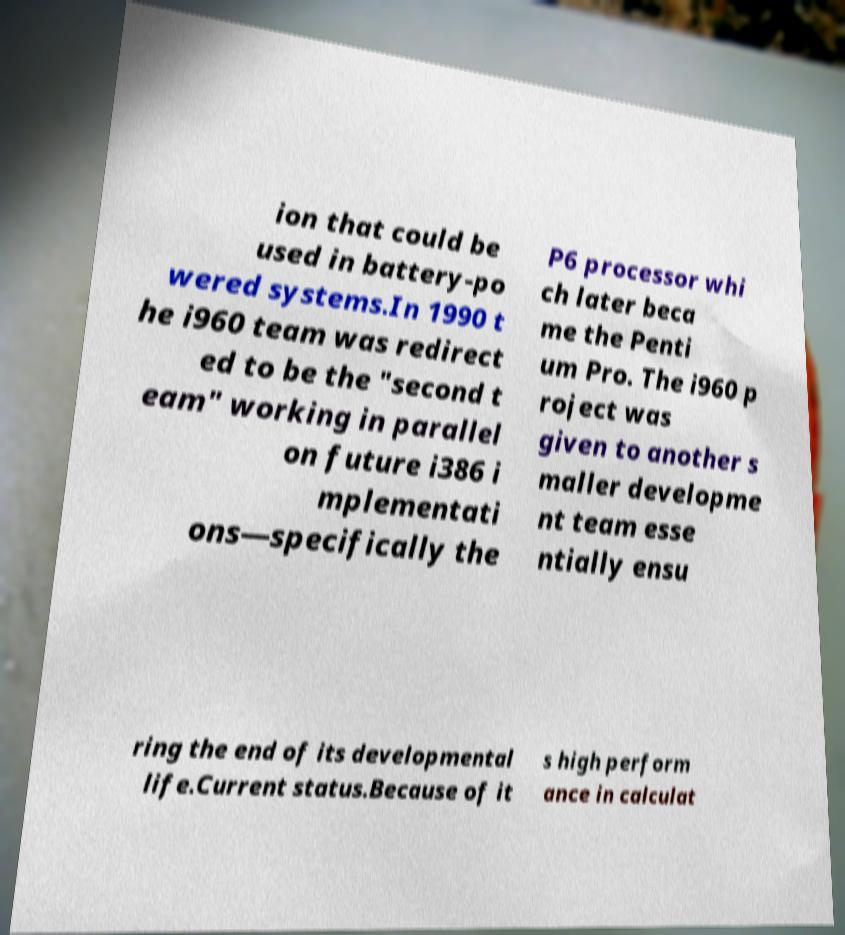Can you read and provide the text displayed in the image?This photo seems to have some interesting text. Can you extract and type it out for me? ion that could be used in battery-po wered systems.In 1990 t he i960 team was redirect ed to be the "second t eam" working in parallel on future i386 i mplementati ons—specifically the P6 processor whi ch later beca me the Penti um Pro. The i960 p roject was given to another s maller developme nt team esse ntially ensu ring the end of its developmental life.Current status.Because of it s high perform ance in calculat 